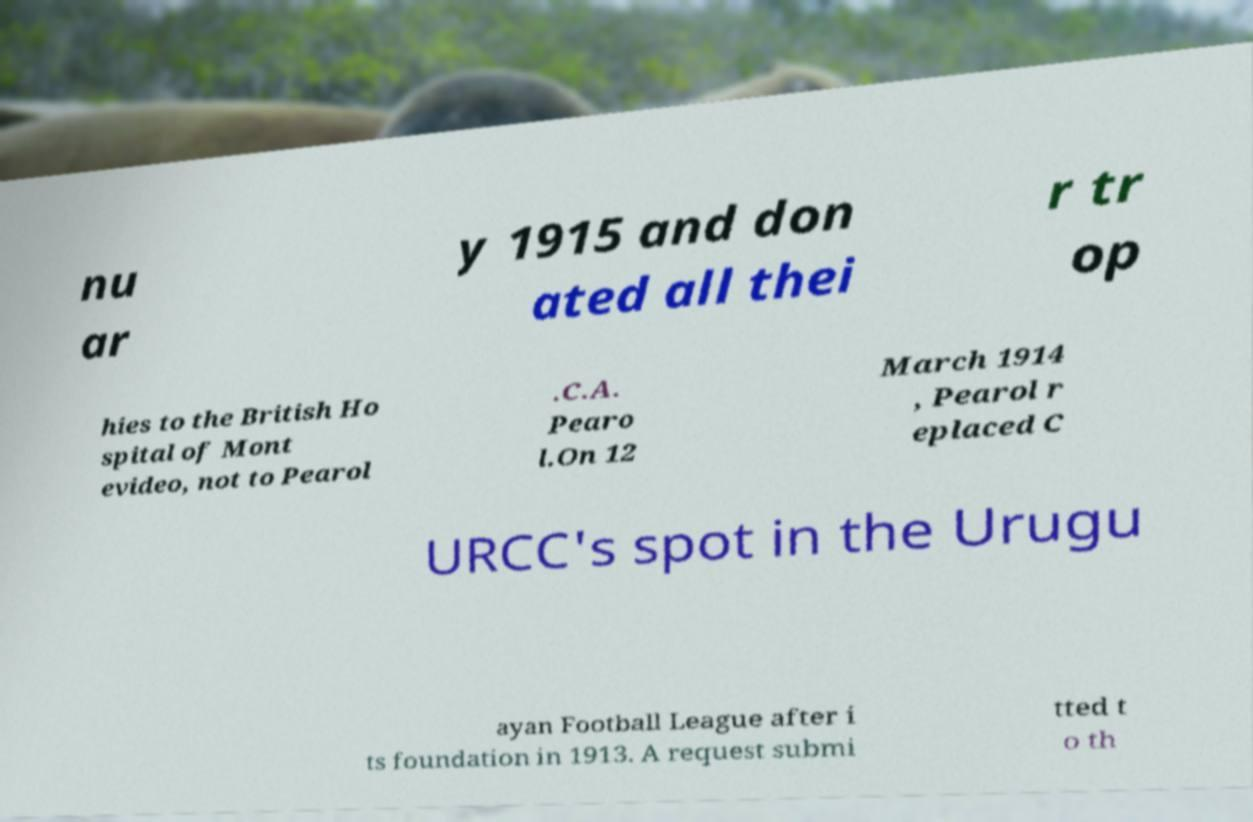For documentation purposes, I need the text within this image transcribed. Could you provide that? nu ar y 1915 and don ated all thei r tr op hies to the British Ho spital of Mont evideo, not to Pearol .C.A. Pearo l.On 12 March 1914 , Pearol r eplaced C URCC's spot in the Urugu ayan Football League after i ts foundation in 1913. A request submi tted t o th 